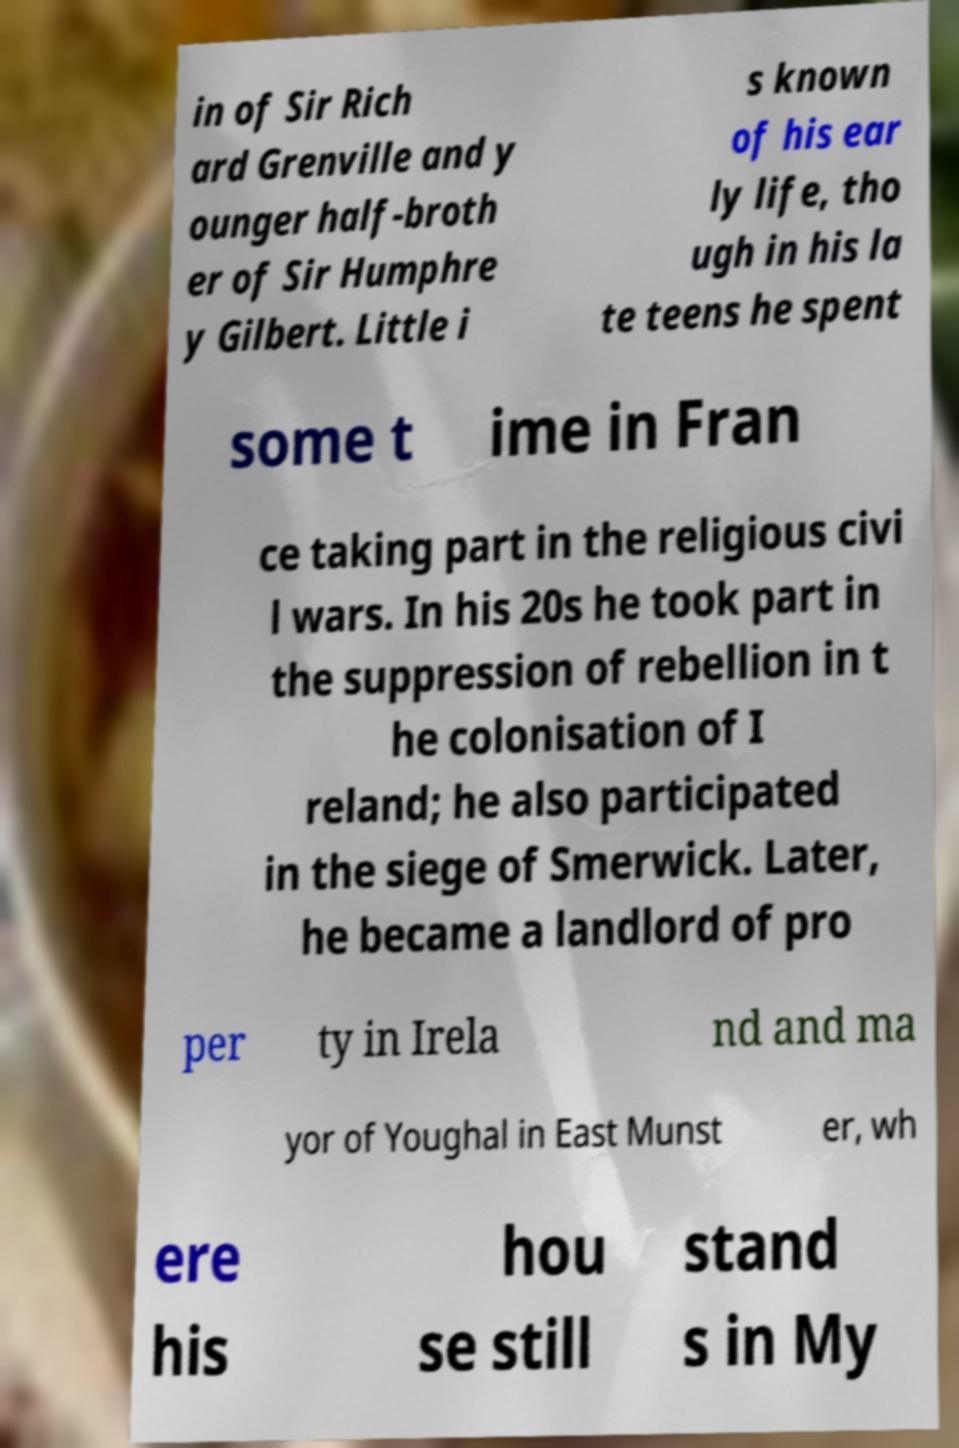Could you assist in decoding the text presented in this image and type it out clearly? in of Sir Rich ard Grenville and y ounger half-broth er of Sir Humphre y Gilbert. Little i s known of his ear ly life, tho ugh in his la te teens he spent some t ime in Fran ce taking part in the religious civi l wars. In his 20s he took part in the suppression of rebellion in t he colonisation of I reland; he also participated in the siege of Smerwick. Later, he became a landlord of pro per ty in Irela nd and ma yor of Youghal in East Munst er, wh ere his hou se still stand s in My 